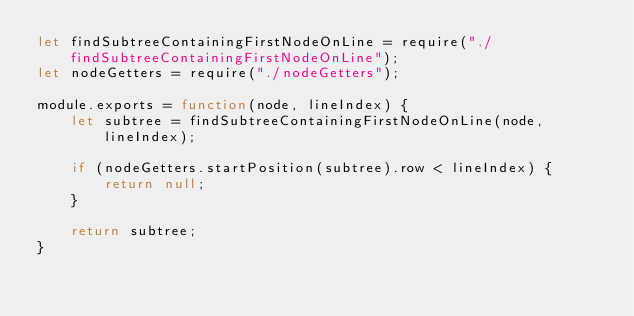Convert code to text. <code><loc_0><loc_0><loc_500><loc_500><_JavaScript_>let findSubtreeContainingFirstNodeOnLine = require("./findSubtreeContainingFirstNodeOnLine");
let nodeGetters = require("./nodeGetters");

module.exports = function(node, lineIndex) {
	let subtree = findSubtreeContainingFirstNodeOnLine(node, lineIndex);
	
	if (nodeGetters.startPosition(subtree).row < lineIndex) {
		return null;
	}
	
	return subtree;
}
</code> 